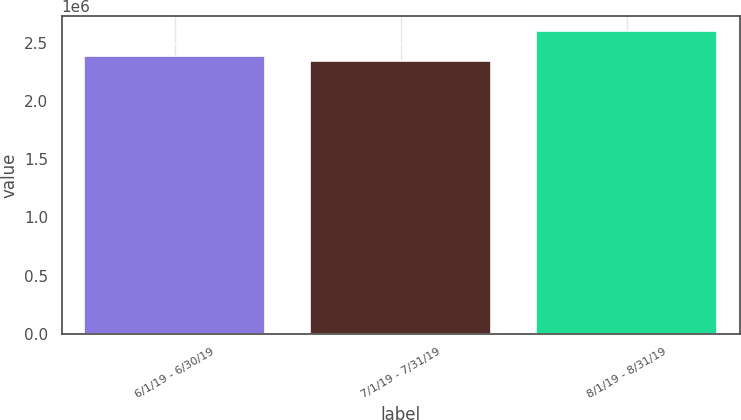Convert chart to OTSL. <chart><loc_0><loc_0><loc_500><loc_500><bar_chart><fcel>6/1/19 - 6/30/19<fcel>7/1/19 - 7/31/19<fcel>8/1/19 - 8/31/19<nl><fcel>2.3846e+06<fcel>2.34849e+06<fcel>2.5984e+06<nl></chart> 